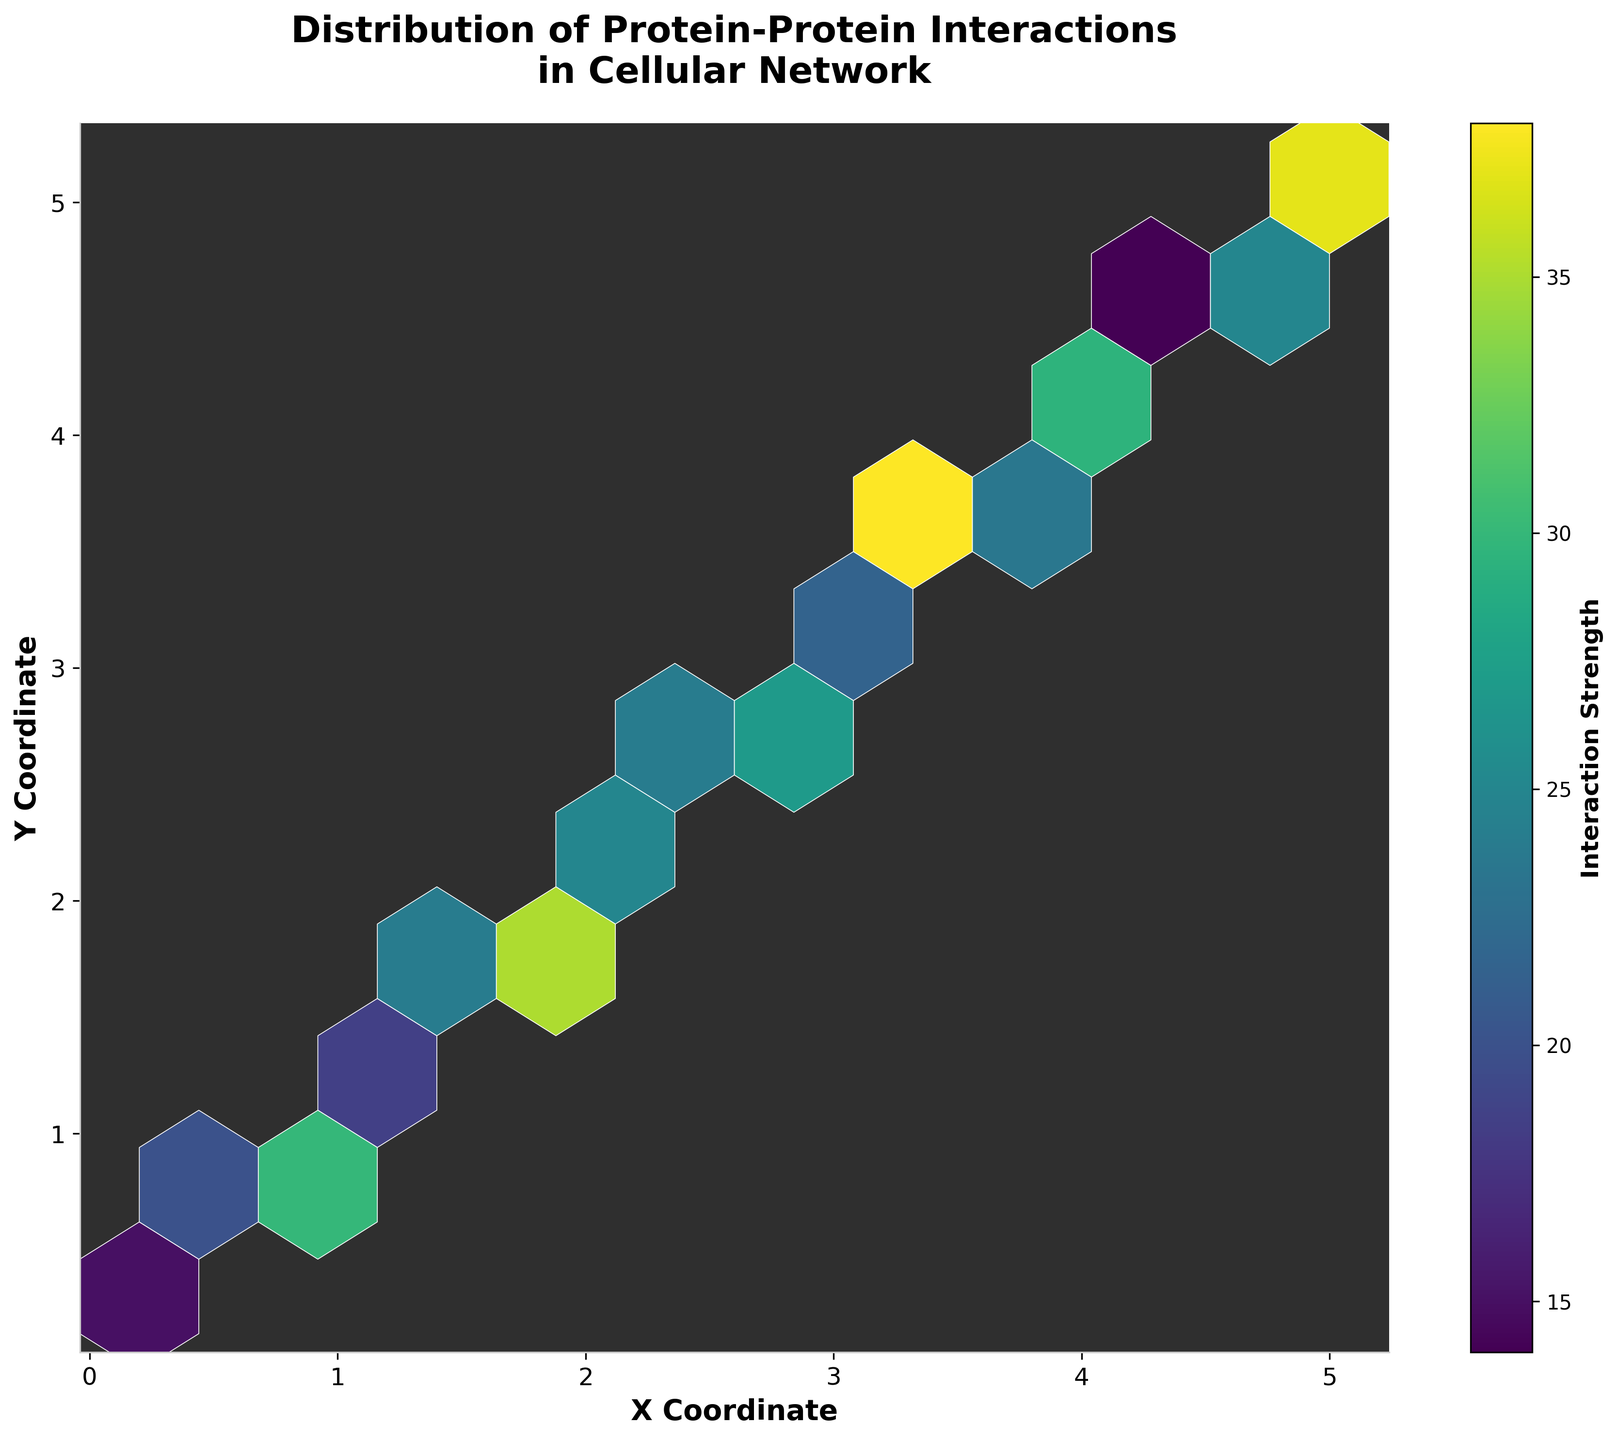What is the title of the hexbin plot? The title can be found at the top of the plot. It reads 'Distribution of Protein-Protein Interactions in Cellular Network'.
Answer: Distribution of Protein-Protein Interactions in Cellular Network What is shown on the x-axis? The label on the x-axis indicates what it represents. It reads 'X Coordinate'.
Answer: X Coordinate How many hexagonal bins have the highest interaction strength? The color bar indicates interaction strength. The deepest color represents the highest value. By counting the bins with the deepest color, we can determine the number.
Answer: 1 Which color represents the highest interaction strength in the plot? Interaction strength is represented by the color of the bins. The color bar shows that the highest interaction strength is represented by the color corresponding to the maximum value on the color gradient.
Answer: Bright Yellow What does the color bar label represent? The color bar label is located next to the color bar and indicates what the gradient of colors represents. It reads 'Interaction Strength'.
Answer: Interaction Strength In which coordinate region is the interaction strength highest? By examining the color intensity on the hexbin plot, we can identify the region where the color is the most intense, indicating the highest interaction strength. This appears to be around (2.2, 2.3).
Answer: Around (2.2, 2.3) What is the average interaction strength of the bins located at coordinates (1.0, 1.1) and (3.2, 3.3)? Interaction strengths for these coordinates are 25 and 24 respectively. Average = (25 + 24) / 2 = 24.5.
Answer: 24.5 Compare the interaction strengths at (4.2, 4.3) and (0.6, 0.7). Which one is higher? The interaction strengths at coordinates (4.2, 4.3) and (0.6, 0.7) are 36 and 18 respectively. Therefore, 36 is higher than 18.
Answer: (4.2, 4.3) How does the interaction strength at (1.8, 1.9) compare to the interaction strength at (4.4, 4.5)? The interaction strength at (1.8, 1.9) is 35, while at (4.4, 4.5) it is 14. Therefore, 35 is greater than 14.
Answer: (1.8, 1.9) is higher What is the range of the interaction strengths represented in the plot? The interaction strengths range from a minimum value to a maximum value. The color bar indicates the minimum and maximum values, which are 10 and 40 respectively.
Answer: 10-40 Which bin represents an outlier in terms of interaction strength? An outlier might be indicated by a bin that stands out with a color very different from the surrounding bins. This can typically be seen as an unusually bright or dark color. From evaluating the plot, the bin near (2.2, 2.3) as the highest value is an outlier.
Answer: (2.2, 2.3) 